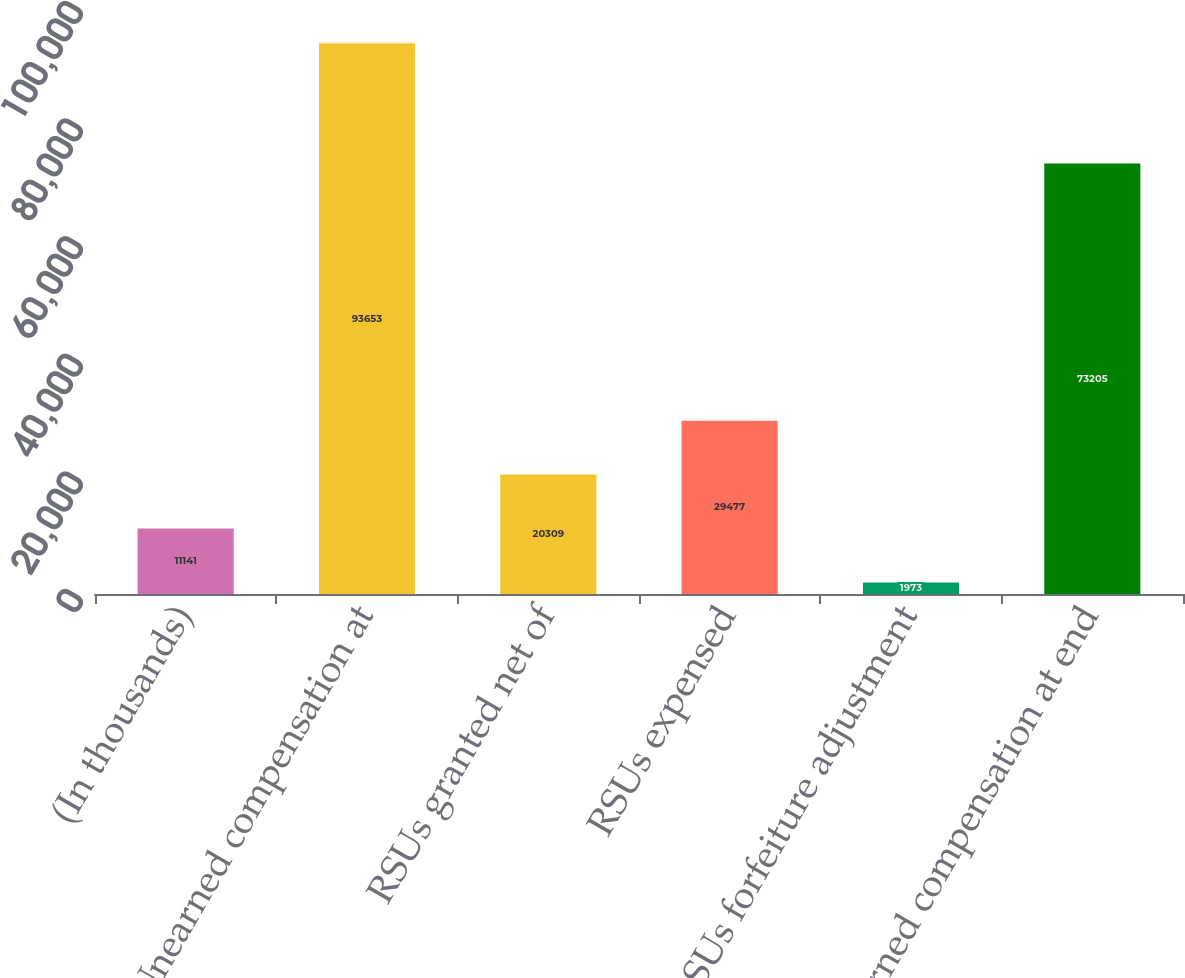<chart> <loc_0><loc_0><loc_500><loc_500><bar_chart><fcel>(In thousands)<fcel>Unearned compensation at<fcel>RSUs granted net of<fcel>RSUs expensed<fcel>RSUs forfeiture adjustment<fcel>Unearned compensation at end<nl><fcel>11141<fcel>93653<fcel>20309<fcel>29477<fcel>1973<fcel>73205<nl></chart> 